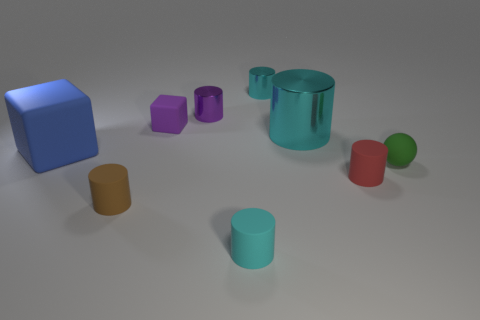How many cyan cylinders must be subtracted to get 1 cyan cylinders? 2 Subtract all red spheres. How many cyan cylinders are left? 3 Subtract 1 cylinders. How many cylinders are left? 5 Subtract all brown cylinders. How many cylinders are left? 5 Subtract all large cyan shiny cylinders. How many cylinders are left? 5 Subtract all cyan cylinders. Subtract all red cubes. How many cylinders are left? 3 Add 1 large gray matte blocks. How many objects exist? 10 Subtract all cylinders. How many objects are left? 3 Subtract all small purple rubber cubes. Subtract all brown things. How many objects are left? 7 Add 7 purple objects. How many purple objects are left? 9 